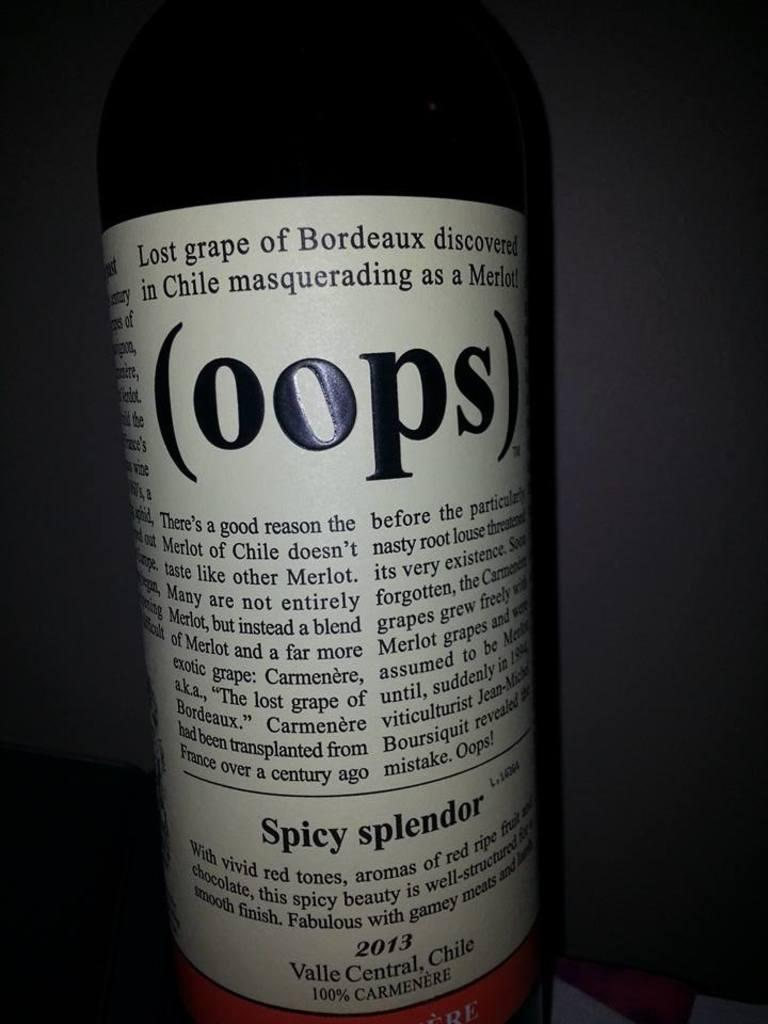Provide a one-sentence caption for the provided image. Wine bottle with a label that says OOPS on it. 